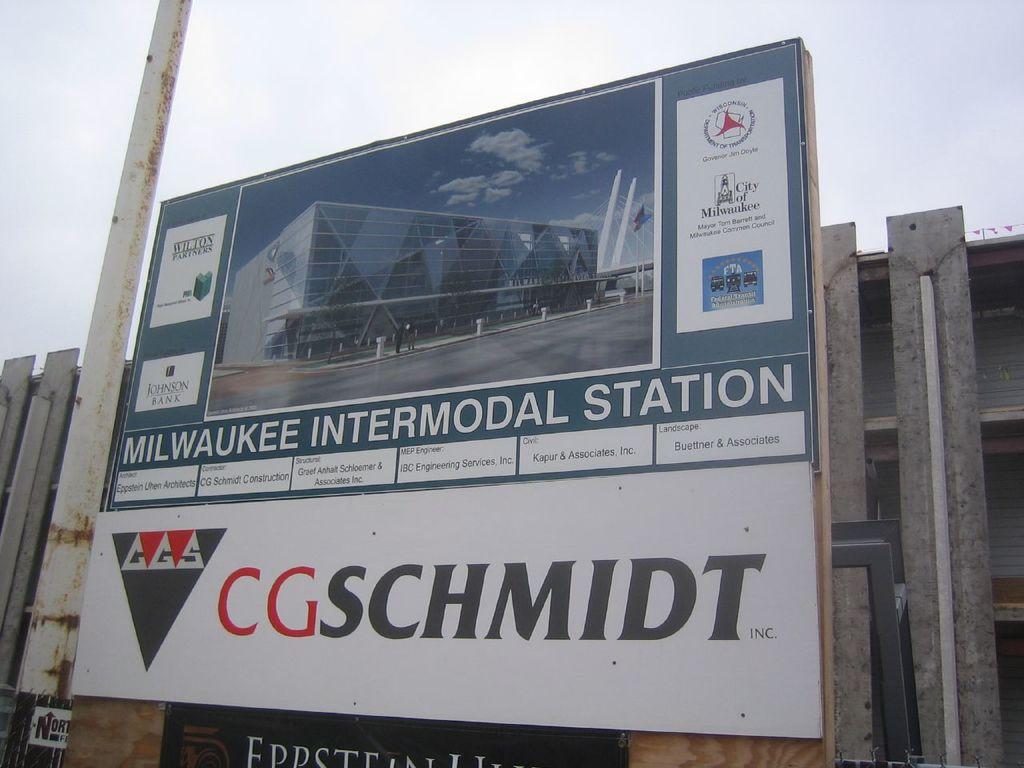Can you please tell me which train station we're at now?
Offer a very short reply. Milwaukee intermodal station. What does it say on the bottom?
Keep it short and to the point. Cgschmidt. 